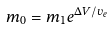Convert formula to latex. <formula><loc_0><loc_0><loc_500><loc_500>m _ { 0 } = m _ { 1 } e ^ { \Delta V / v _ { e } }</formula> 